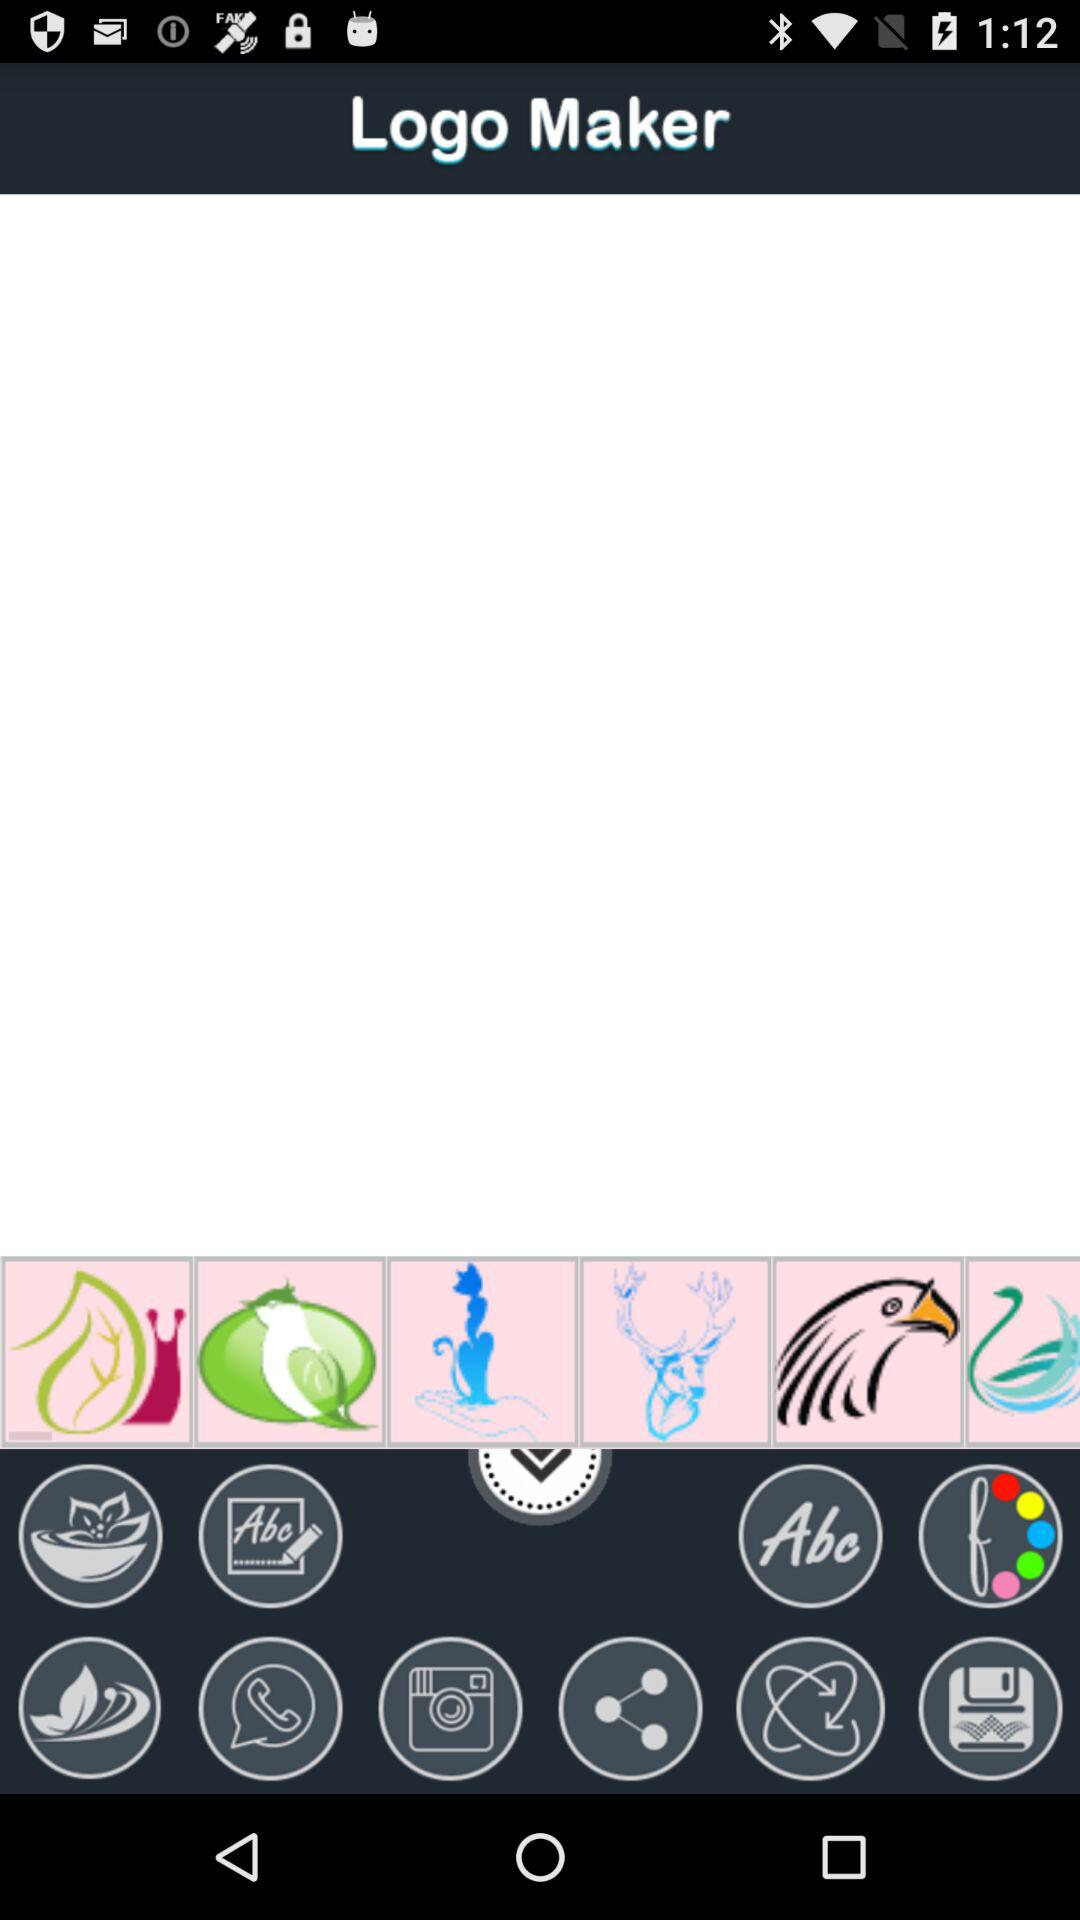What is the application name? The name of the application is "Logo Maker 1.1". 